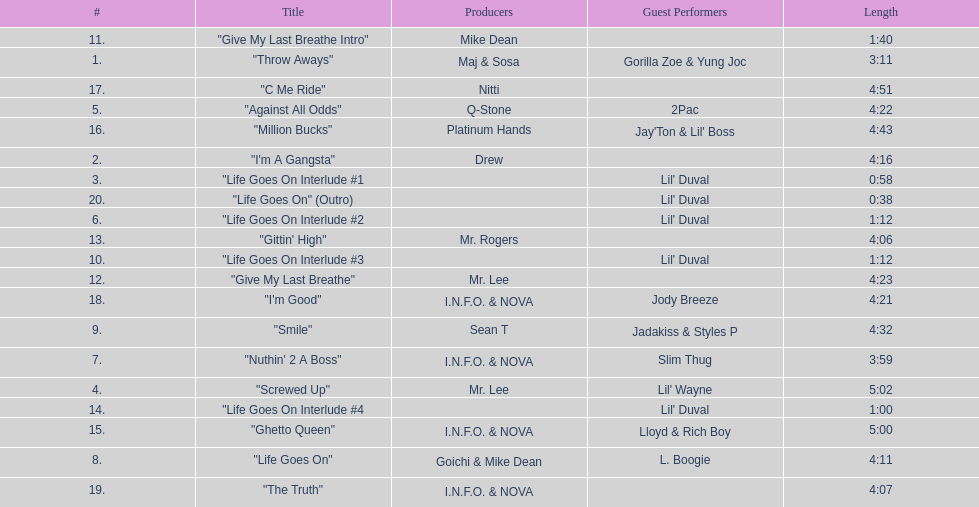How long is the longest track on the album? 5:02. 